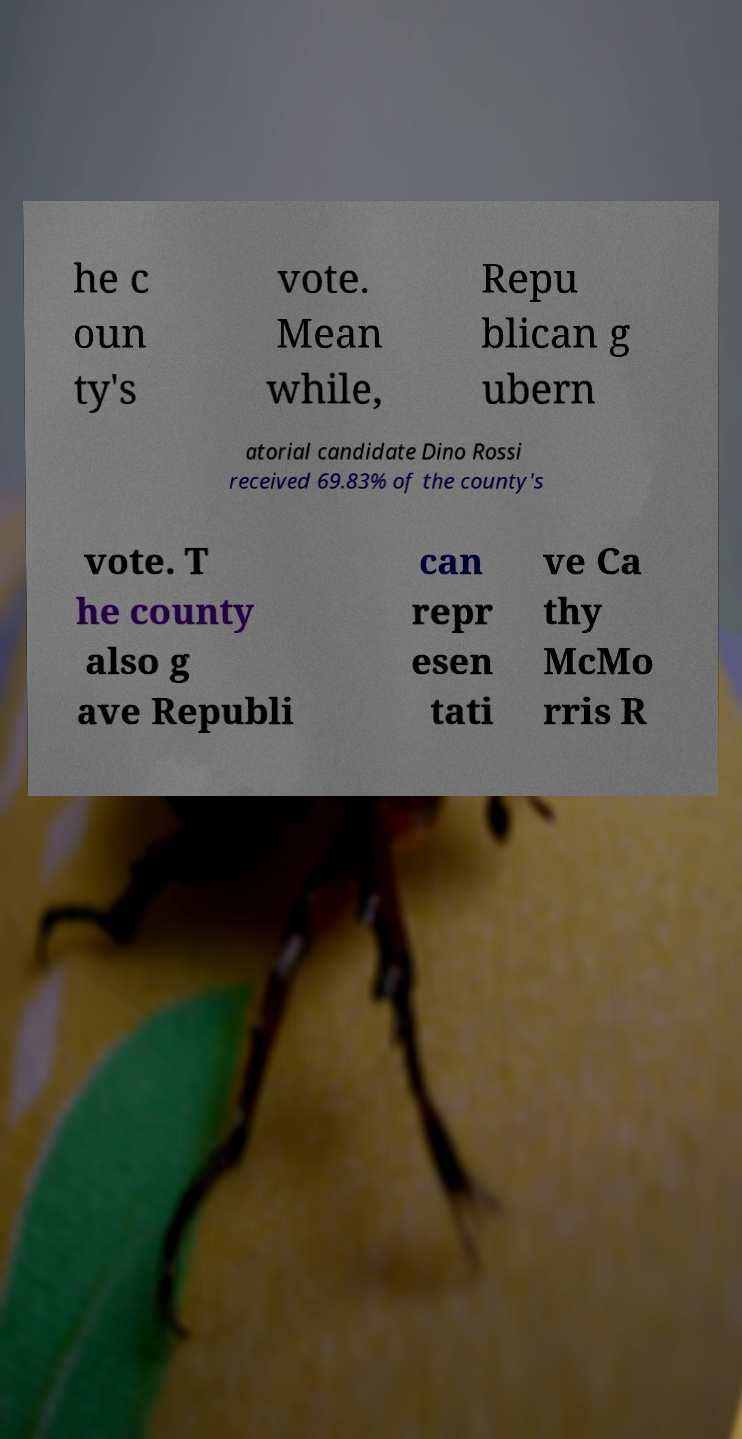Please identify and transcribe the text found in this image. he c oun ty's vote. Mean while, Repu blican g ubern atorial candidate Dino Rossi received 69.83% of the county's vote. T he county also g ave Republi can repr esen tati ve Ca thy McMo rris R 